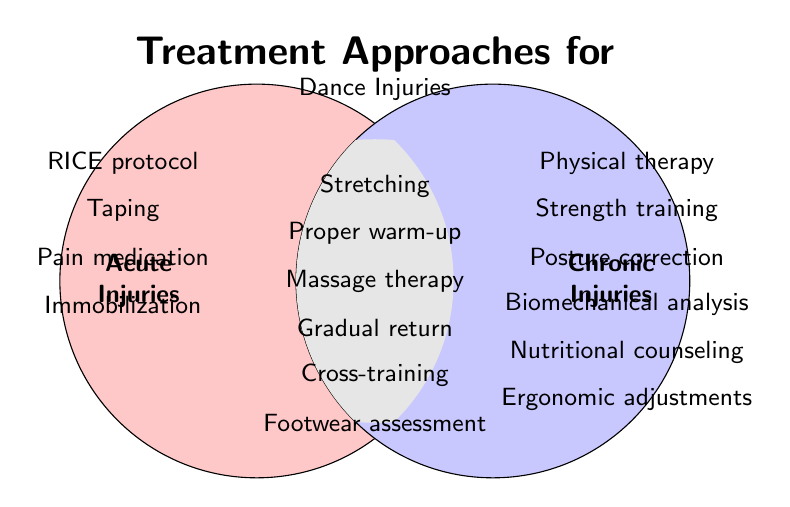What are the treatment approaches for acute injuries? The acute injuries section shows the specific treatments.
Answer: RICE protocol, Taping, Pain medication, Immobilization Which treatment approaches are common to both acute and chronic injuries? The overlapping section between both circles represents the shared treatments.
Answer: Stretching, Proper warm-up, Massage therapy, Gradual return, Cross-training, Footwear assessment What types of treatments are unique to chronic injuries? The right circle (chronic injuries) contains specific treatments.
Answer: Physical therapy, Strength training, Posture correction, Biomechanical analysis, Nutritional counseling, Ergonomic adjustments How many treatment approaches are listed for acute injuries? Count the items in the acute injuries section.
Answer: Four Which treatment approaches from the Venn Diagram could potentially prevent injuries in both acute and chronic cases? Identify the preventive measures in the overlapping area for both acute and chronic injuries.
Answer: Proper warm-up, Stretching, Gradual return, Cross-training, Footwear assessment 